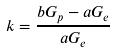Convert formula to latex. <formula><loc_0><loc_0><loc_500><loc_500>k = \frac { b G _ { p } - a G _ { e } } { a G _ { e } }</formula> 